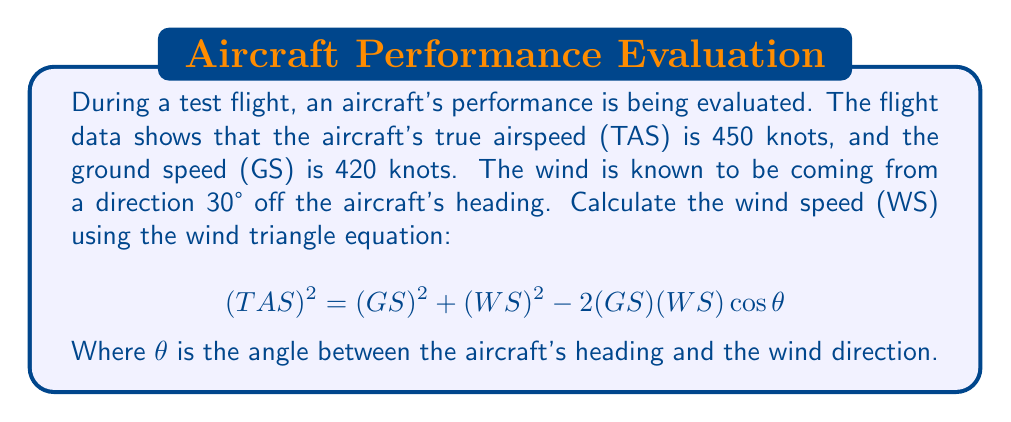Give your solution to this math problem. Let's solve this step-by-step:

1) We are given:
   TAS = 450 knots
   GS = 420 knots
   $\theta$ = 30°

2) Substitute these values into the wind triangle equation:

   $$(450)^2 = (420)^2 + (WS)^2 - 2(420)(WS)\cos{30°}$$

3) Simplify:

   $$202,500 = 176,400 + (WS)^2 - 840(WS)(0.866)$$

   $$202,500 = 176,400 + (WS)^2 - 727.44(WS)$$

4) Subtract 176,400 from both sides:

   $$26,100 = (WS)^2 - 727.44(WS)$$

5) Rearrange to standard quadratic form:

   $$(WS)^2 - 727.44(WS) - 26,100 = 0$$

6) Solve using the quadratic formula: $x = \frac{-b \pm \sqrt{b^2 - 4ac}}{2a}$

   Where $a = 1$, $b = -727.44$, and $c = -26,100$

   $$WS = \frac{727.44 \pm \sqrt{727.44^2 - 4(1)(-26,100)}}{2(1)}$$

7) Simplify:

   $$WS = \frac{727.44 \pm \sqrt{529,169.31 + 104,400}}{2}$$
   
   $$WS = \frac{727.44 \pm \sqrt{633,569.31}}{2}$$

   $$WS = \frac{727.44 \pm 796.0}}{2}$$

8) This gives us two solutions:

   $$WS = \frac{727.44 + 796.0}{2} = 761.72$$ or $$WS = \frac{727.44 - 796.0}{2} = -34.28$$

9) Since wind speed cannot be negative, we take the positive solution.
Answer: 761.72 knots 